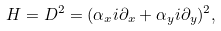Convert formula to latex. <formula><loc_0><loc_0><loc_500><loc_500>H = D ^ { 2 } = ( \alpha _ { x } i \partial _ { x } + \alpha _ { y } i \partial _ { y } ) ^ { 2 } ,</formula> 